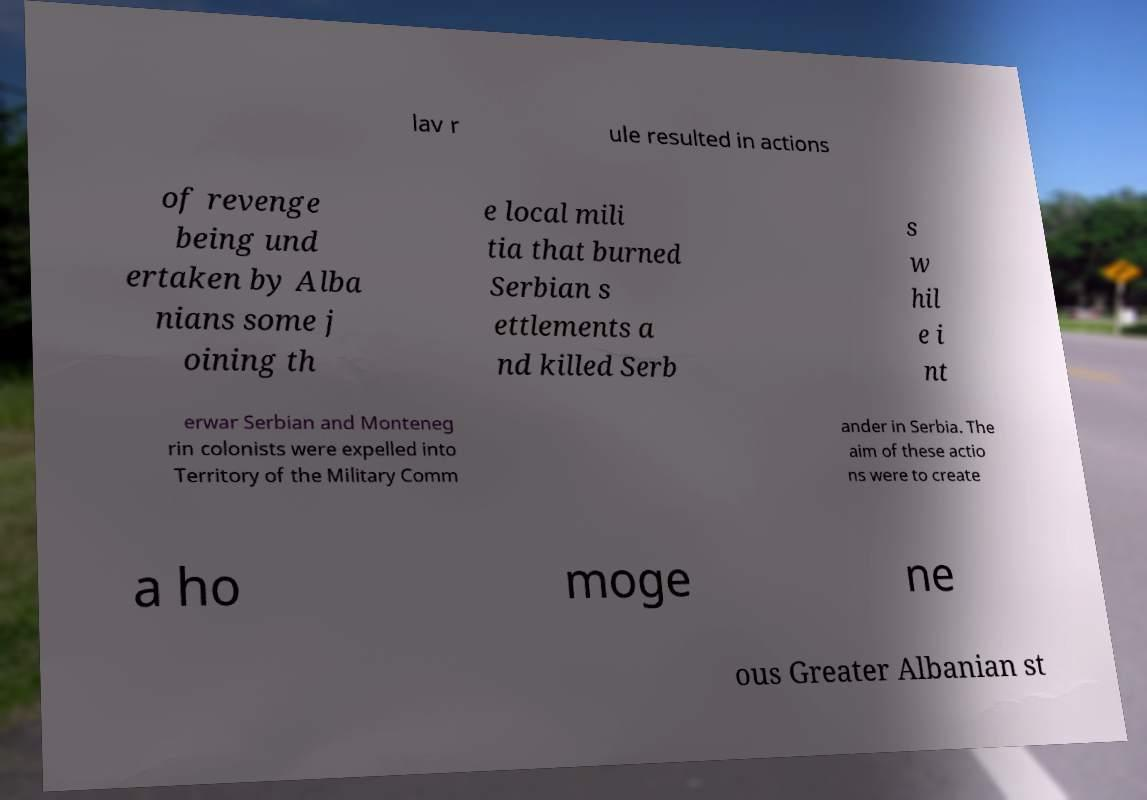Can you read and provide the text displayed in the image?This photo seems to have some interesting text. Can you extract and type it out for me? lav r ule resulted in actions of revenge being und ertaken by Alba nians some j oining th e local mili tia that burned Serbian s ettlements a nd killed Serb s w hil e i nt erwar Serbian and Monteneg rin colonists were expelled into Territory of the Military Comm ander in Serbia. The aim of these actio ns were to create a ho moge ne ous Greater Albanian st 